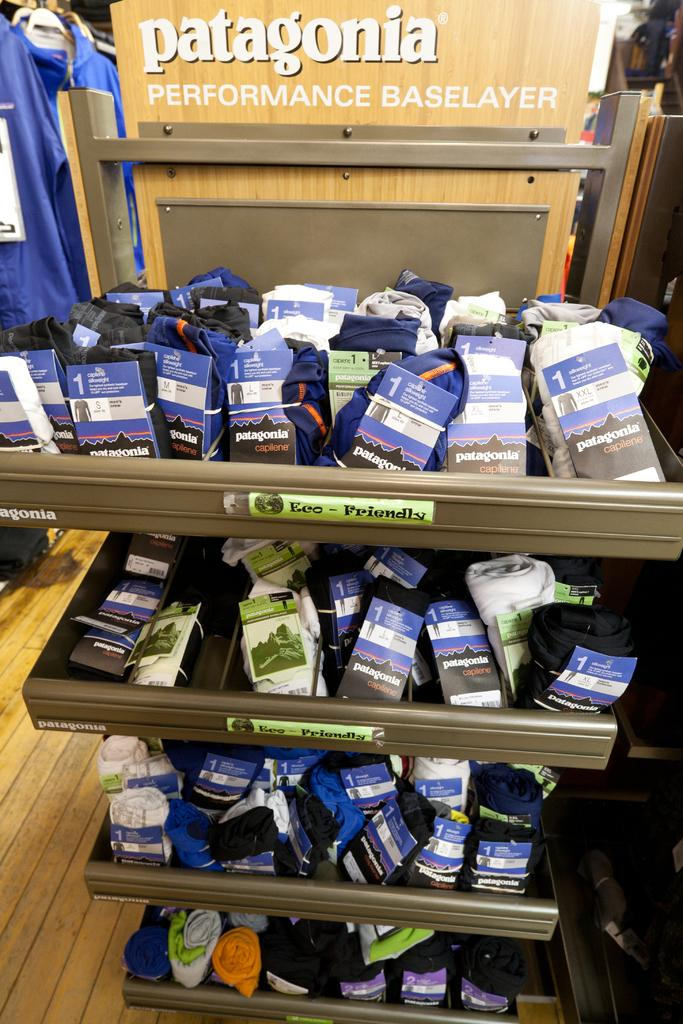What type of items can be found in the racks in the image? There are socks in the racks in the image. What else can be seen in the image besides the socks? There are clothes visible in the image. What is the board in the image used for? The purpose of the board in the image is not specified, but it could be used for displaying or organizing items. Can you describe any other objects present in the image? There are other objects present in the image, but their specific details are not mentioned in the provided facts. What type of bird can be seen perched on the board in the image? There is no bird present in the image; it only features socks in the racks, clothes, and a board. 